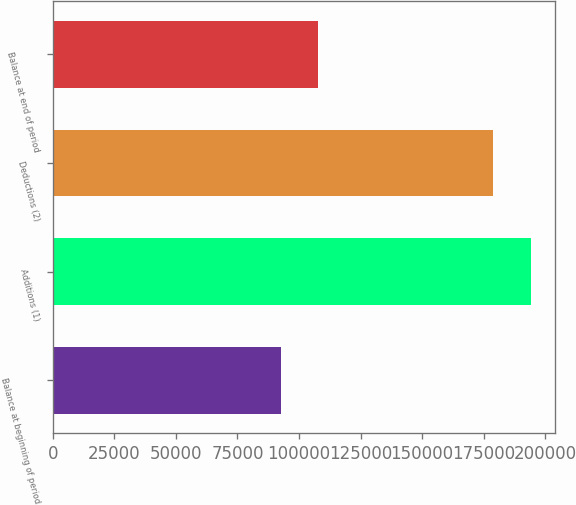Convert chart. <chart><loc_0><loc_0><loc_500><loc_500><bar_chart><fcel>Balance at beginning of period<fcel>Additions (1)<fcel>Deductions (2)<fcel>Balance at end of period<nl><fcel>92655<fcel>194108<fcel>178867<fcel>107896<nl></chart> 